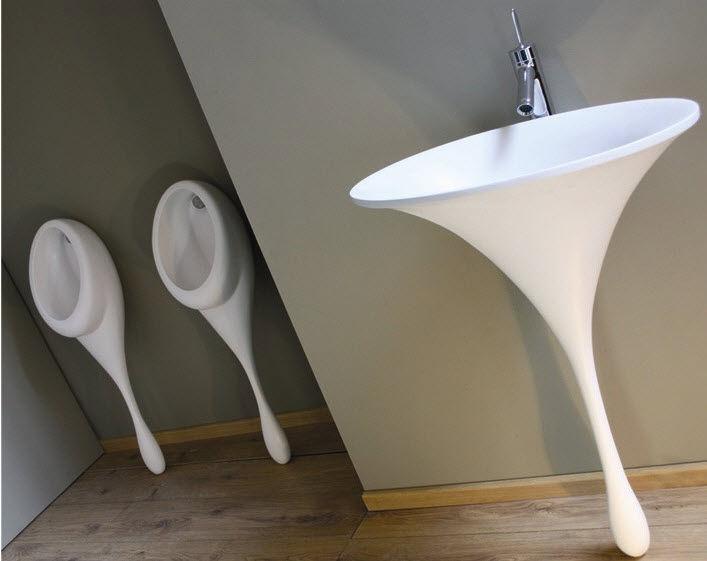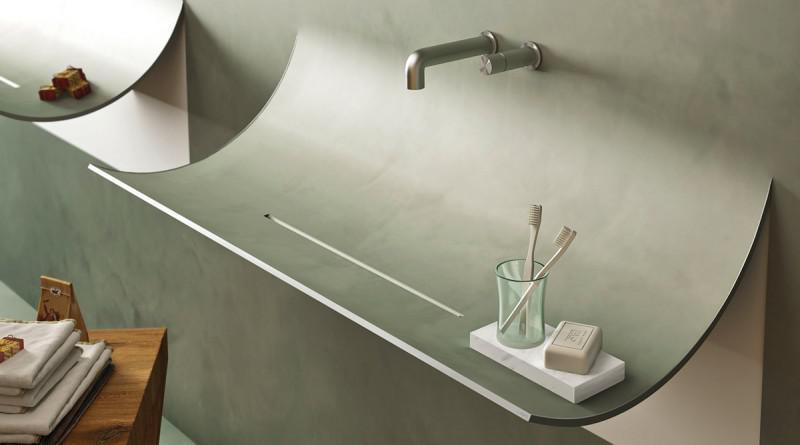The first image is the image on the left, the second image is the image on the right. Evaluate the accuracy of this statement regarding the images: "In one image, two tall narrow sinks are standing side by side, while a second image shows a single sink with a towel.". Is it true? Answer yes or no. No. 